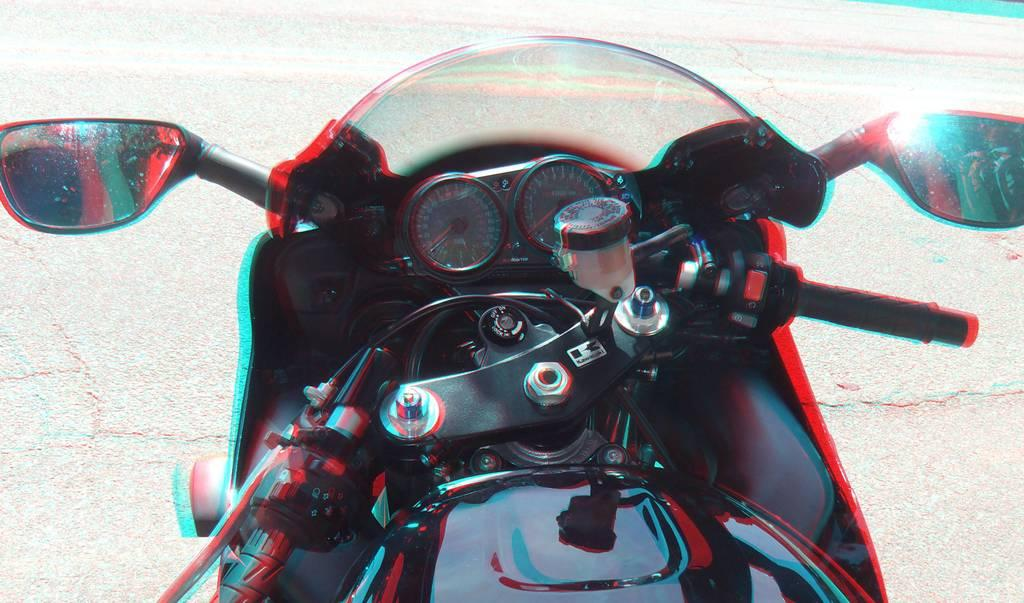What is the main object in the image? There is a bike in the image. How is the bike positioned in relation to other objects? The bike is in front of other objects. What type of surface can be seen in the image? There is a road visible in the image. Can you tell if the image has been altered or edited? Yes, the image appears to be edited. Where is the aunt standing in the image? There is no aunt present in the image. What type of ground is visible in the image? The image does not show the ground; it shows a road. Can you describe the texture of the bike in the image? The provided facts do not mention the texture of the bike, so it cannot be described. 